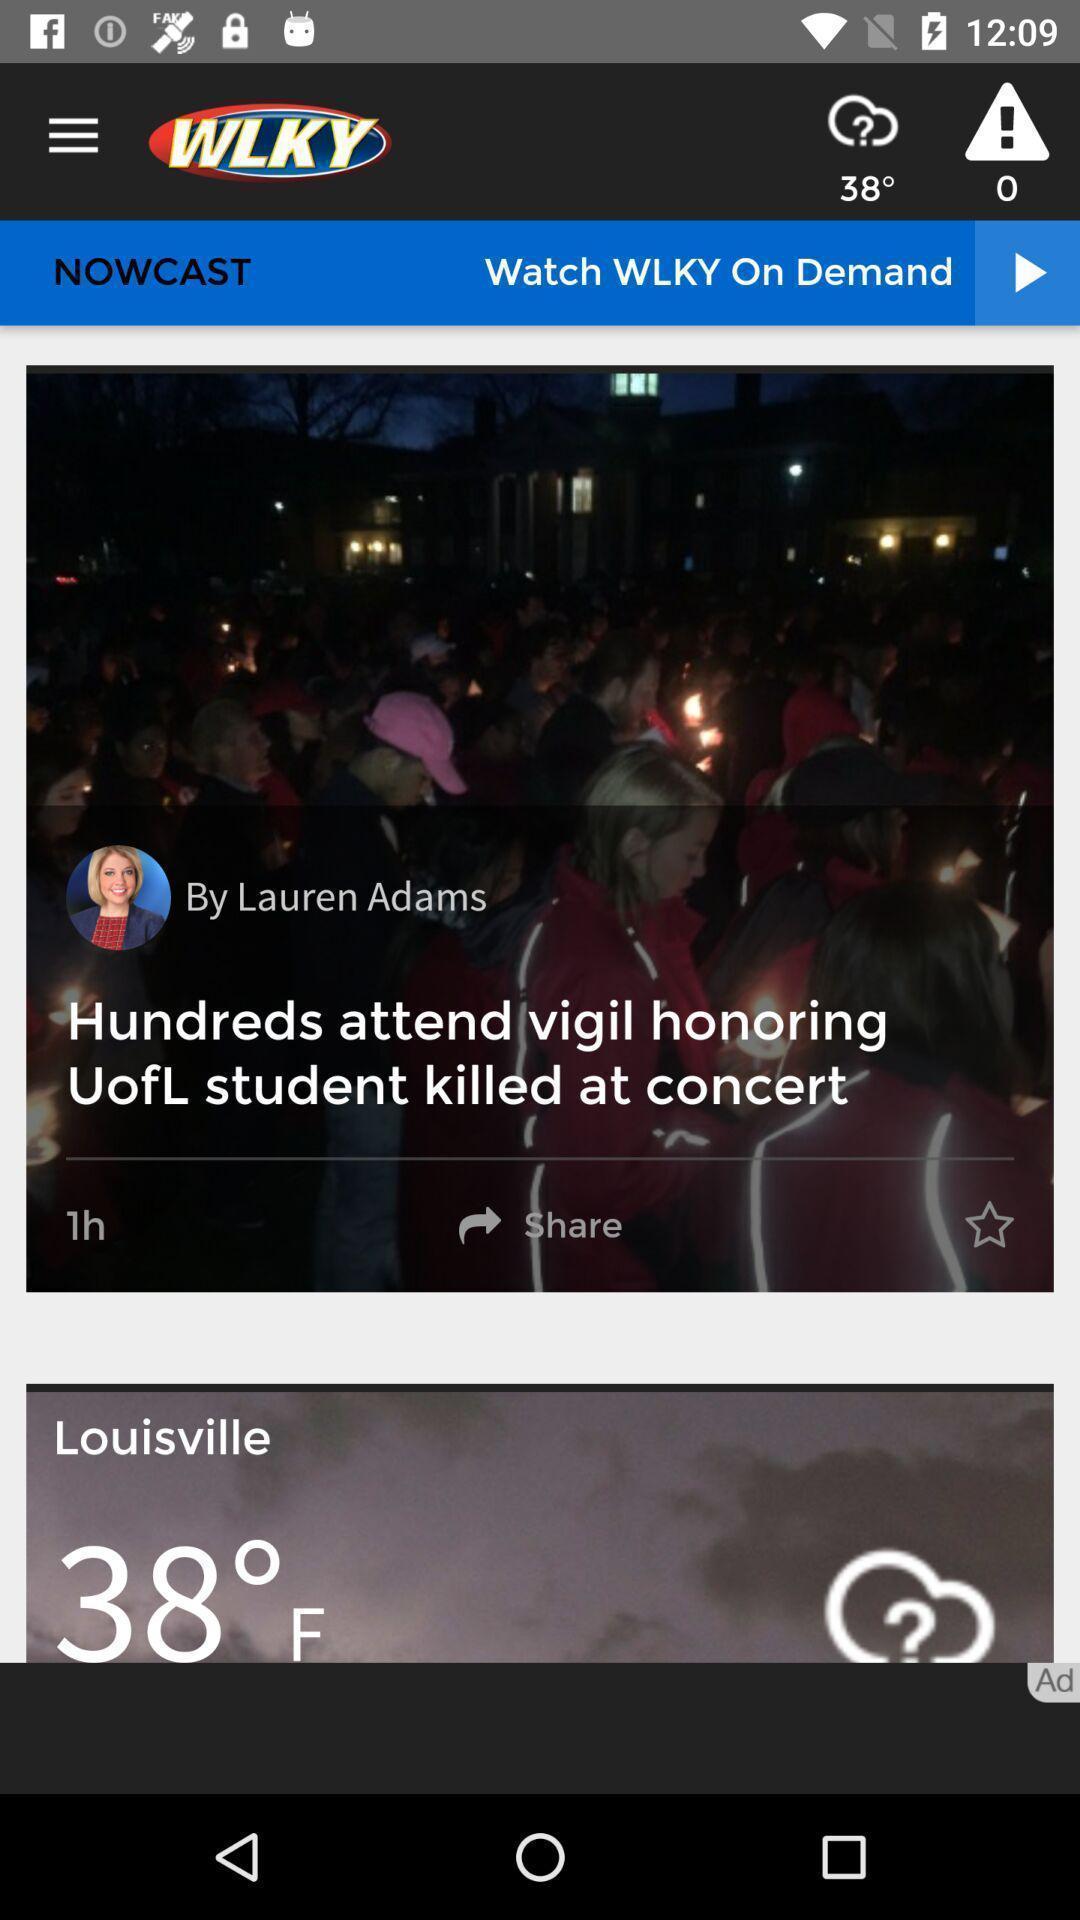What details can you identify in this image? Screen displaying the image and weather condition of location. 